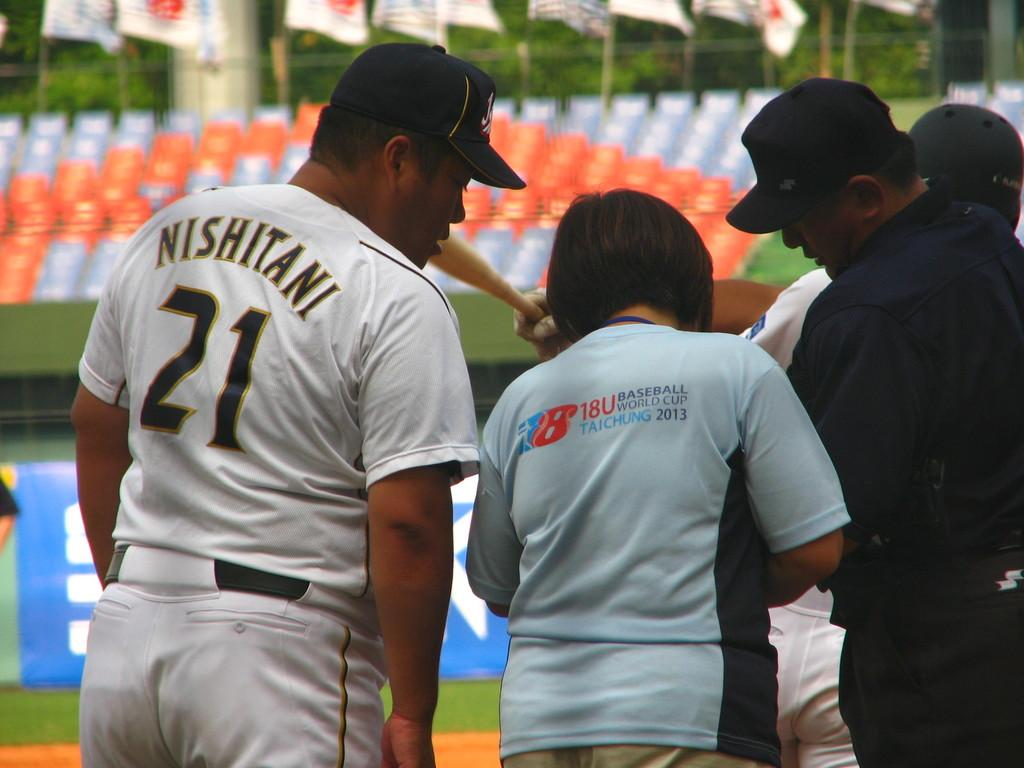Provide a one-sentence caption for the provided image. A heavyset baseball player wears a number 21 uniform. 